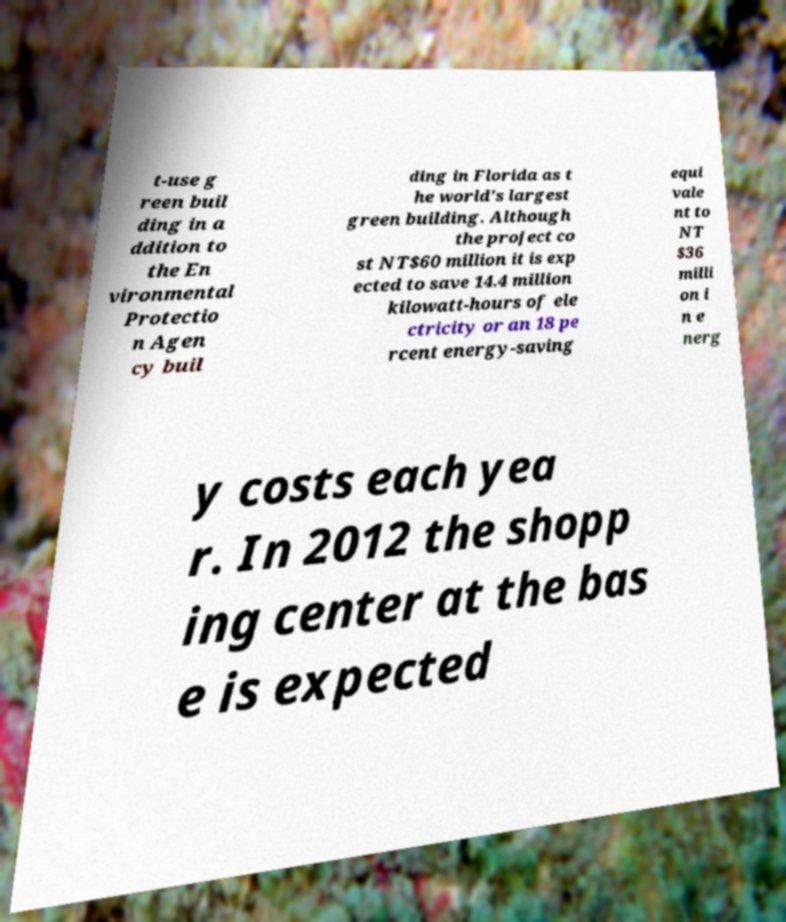Can you accurately transcribe the text from the provided image for me? t-use g reen buil ding in a ddition to the En vironmental Protectio n Agen cy buil ding in Florida as t he world's largest green building. Although the project co st NT$60 million it is exp ected to save 14.4 million kilowatt-hours of ele ctricity or an 18 pe rcent energy-saving equi vale nt to NT $36 milli on i n e nerg y costs each yea r. In 2012 the shopp ing center at the bas e is expected 